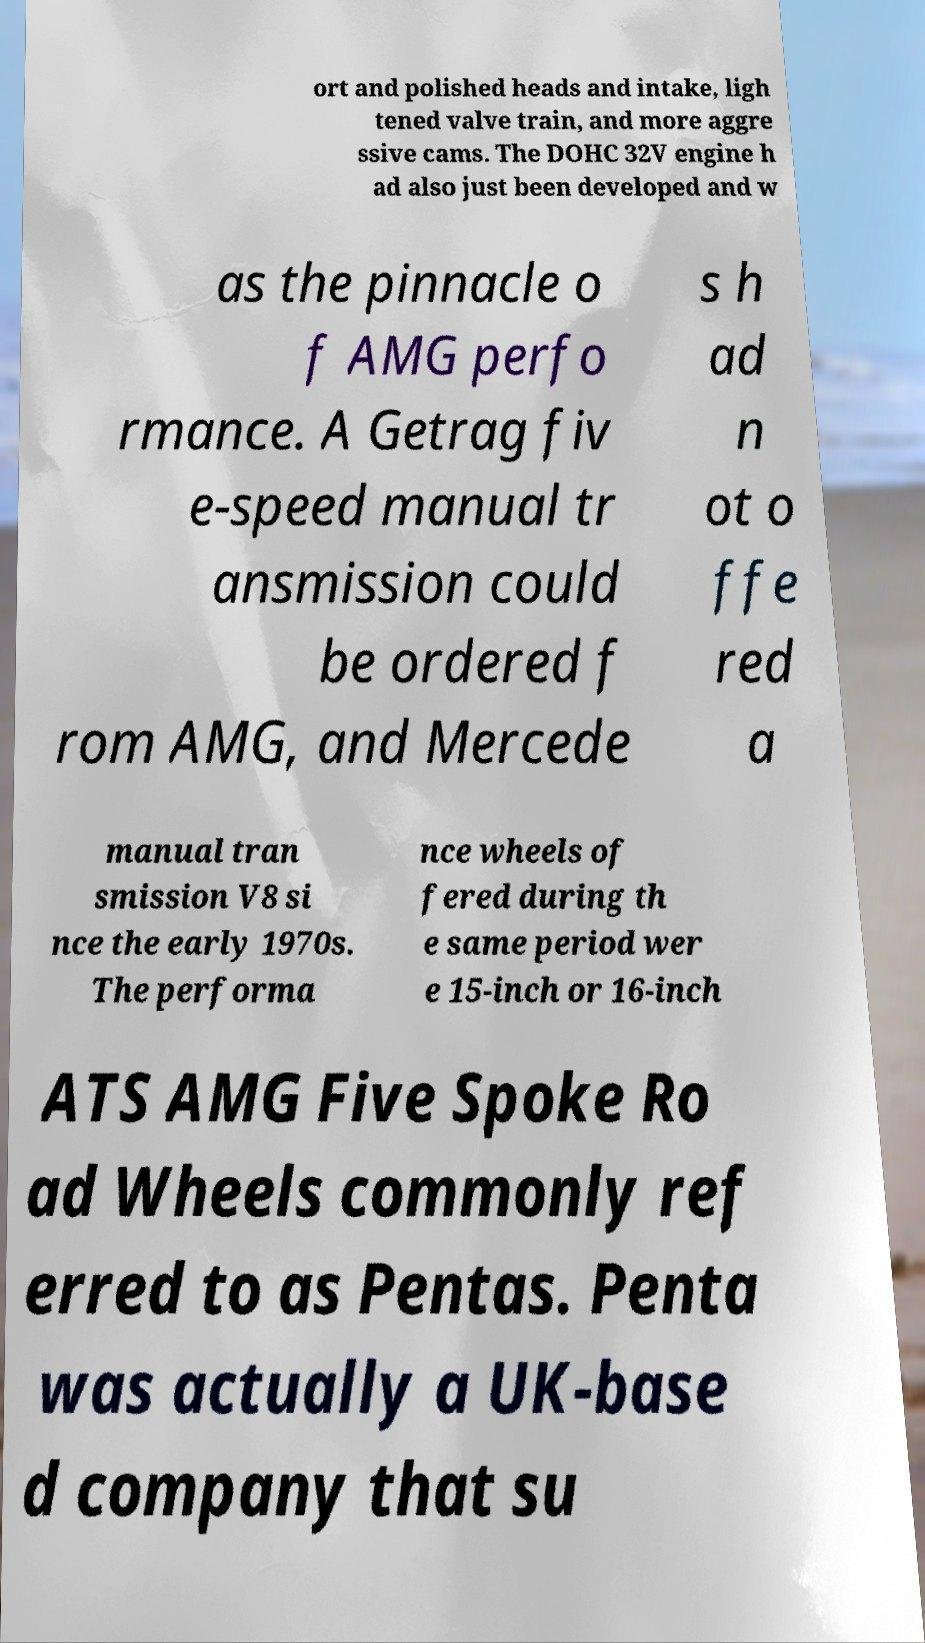I need the written content from this picture converted into text. Can you do that? ort and polished heads and intake, ligh tened valve train, and more aggre ssive cams. The DOHC 32V engine h ad also just been developed and w as the pinnacle o f AMG perfo rmance. A Getrag fiv e-speed manual tr ansmission could be ordered f rom AMG, and Mercede s h ad n ot o ffe red a manual tran smission V8 si nce the early 1970s. The performa nce wheels of fered during th e same period wer e 15-inch or 16-inch ATS AMG Five Spoke Ro ad Wheels commonly ref erred to as Pentas. Penta was actually a UK-base d company that su 